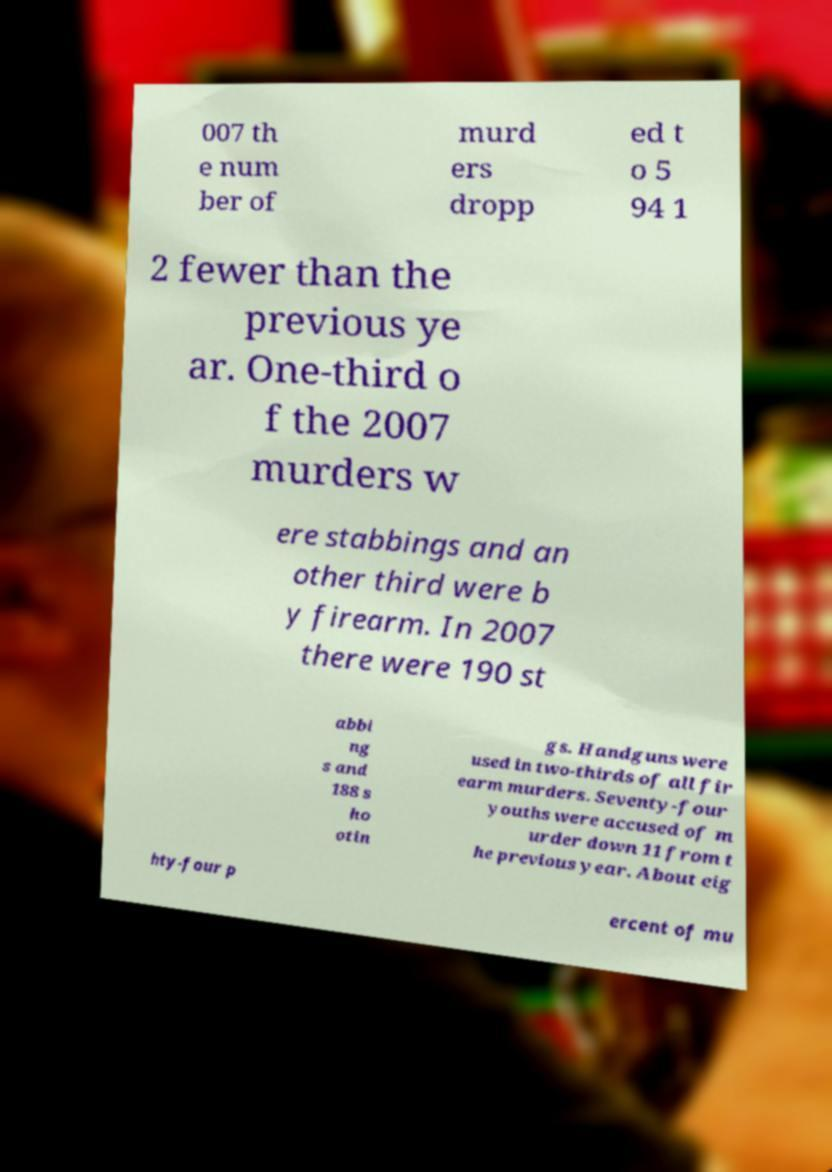Please identify and transcribe the text found in this image. 007 th e num ber of murd ers dropp ed t o 5 94 1 2 fewer than the previous ye ar. One-third o f the 2007 murders w ere stabbings and an other third were b y firearm. In 2007 there were 190 st abbi ng s and 188 s ho otin gs. Handguns were used in two-thirds of all fir earm murders. Seventy-four youths were accused of m urder down 11 from t he previous year. About eig hty-four p ercent of mu 